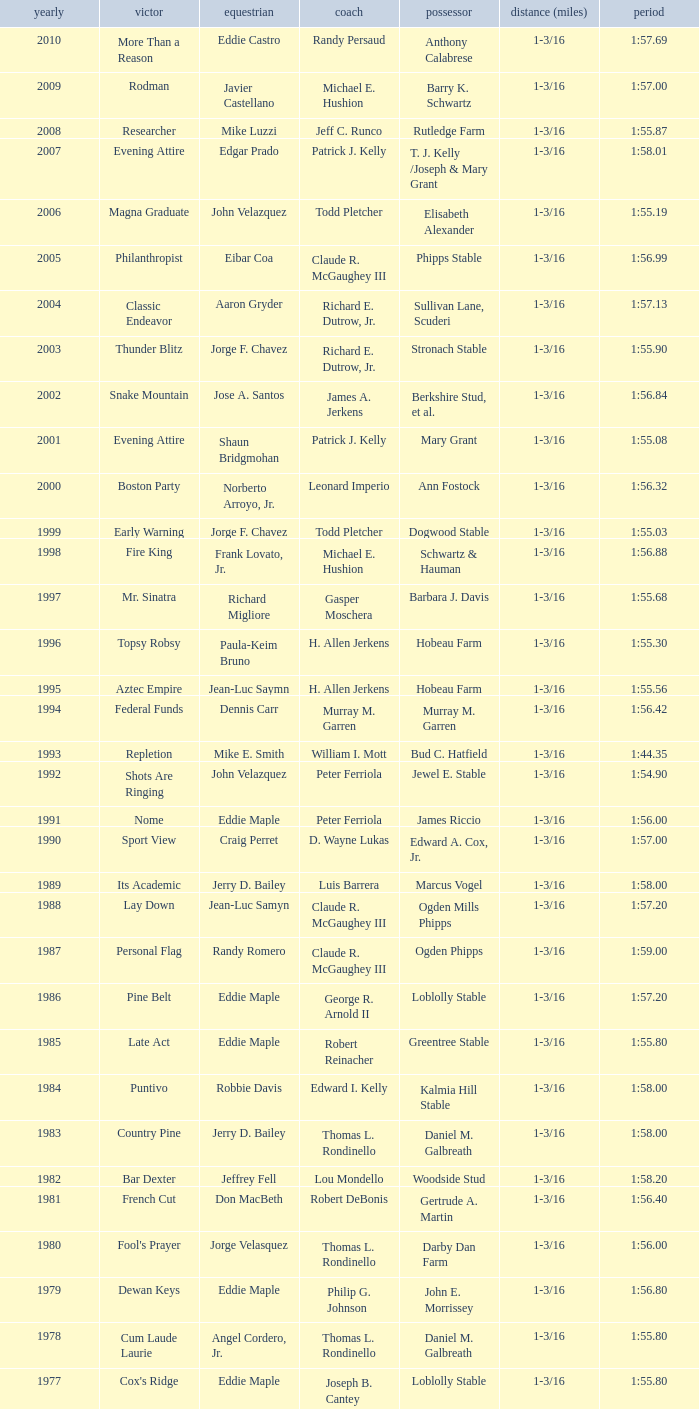Who was the jockey for the winning horse Helioptic? Paul Miller. 